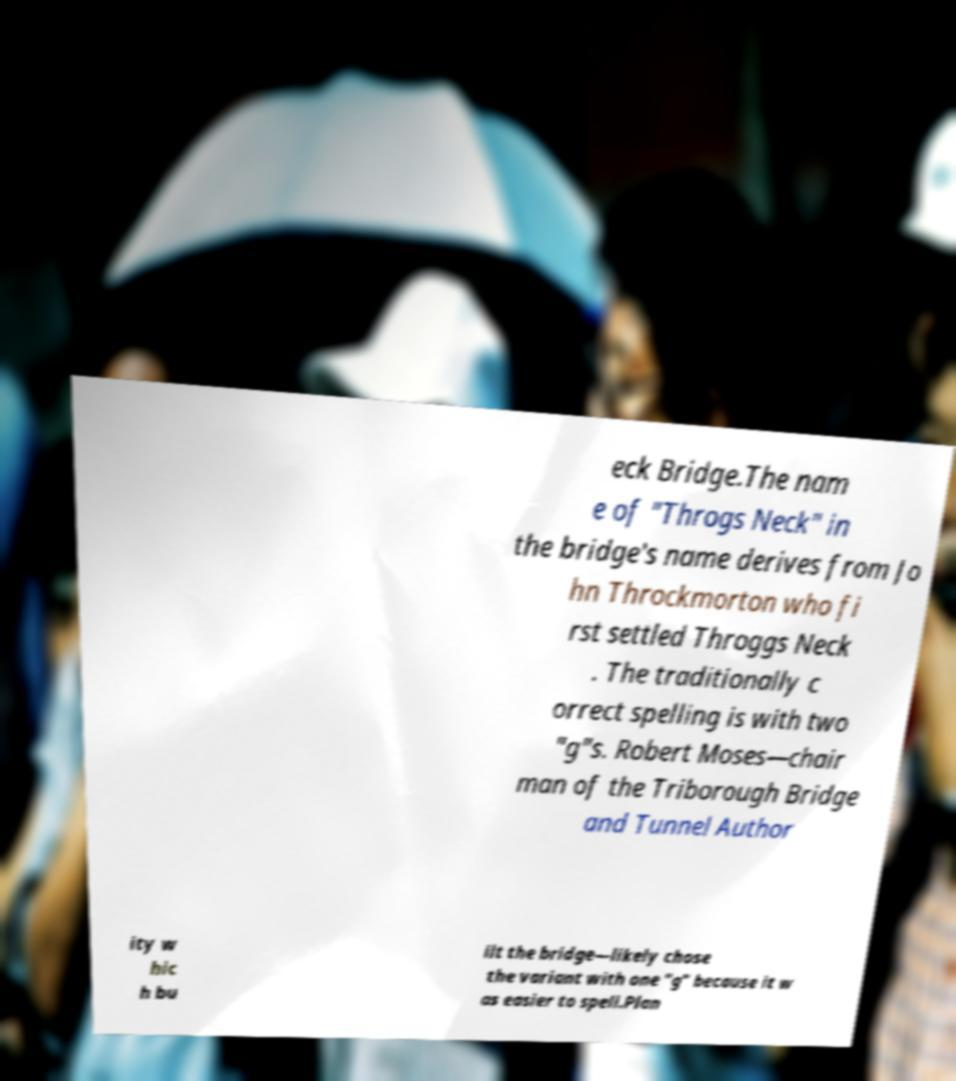Can you read and provide the text displayed in the image?This photo seems to have some interesting text. Can you extract and type it out for me? eck Bridge.The nam e of "Throgs Neck" in the bridge's name derives from Jo hn Throckmorton who fi rst settled Throggs Neck . The traditionally c orrect spelling is with two "g"s. Robert Moses—chair man of the Triborough Bridge and Tunnel Author ity w hic h bu ilt the bridge—likely chose the variant with one "g" because it w as easier to spell.Plan 